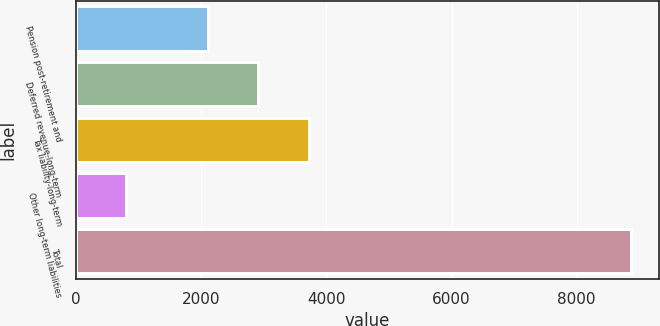Convert chart. <chart><loc_0><loc_0><loc_500><loc_500><bar_chart><fcel>Pension post-retirement and<fcel>Deferred revenue-long-term<fcel>Tax liability-long-term<fcel>Other long-term liabilities<fcel>Total<nl><fcel>2101<fcel>2908.2<fcel>3715.4<fcel>802<fcel>8874<nl></chart> 